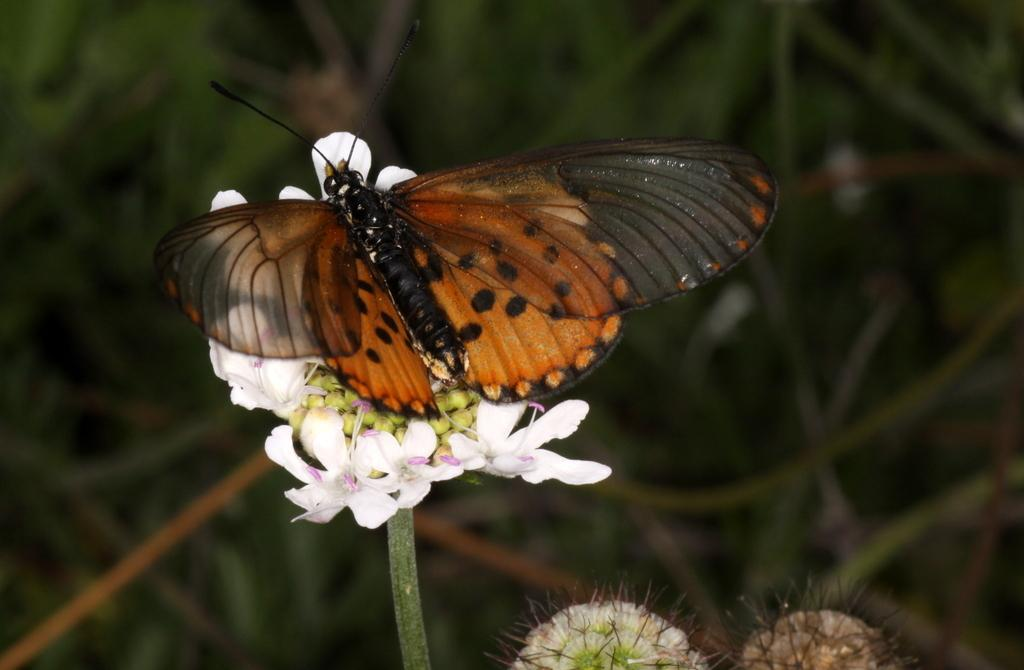What is the main subject of the image? There is a butterfly in the image. Where is the butterfly located? The butterfly is on a flower. What can be seen in the background of the image? There are leaves visible in the background of the image. How would you describe the background of the image? The background appears blurry. What direction is the frog facing in the image? There is no frog present in the image. 